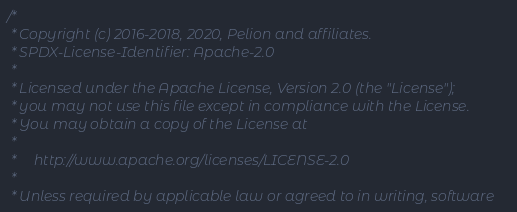<code> <loc_0><loc_0><loc_500><loc_500><_C_>/*
 * Copyright (c) 2016-2018, 2020, Pelion and affiliates.
 * SPDX-License-Identifier: Apache-2.0
 *
 * Licensed under the Apache License, Version 2.0 (the "License");
 * you may not use this file except in compliance with the License.
 * You may obtain a copy of the License at
 *
 *     http://www.apache.org/licenses/LICENSE-2.0
 *
 * Unless required by applicable law or agreed to in writing, software</code> 